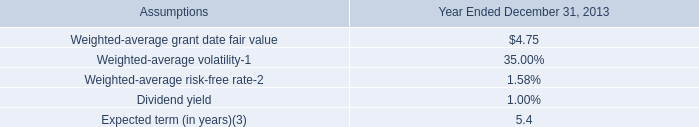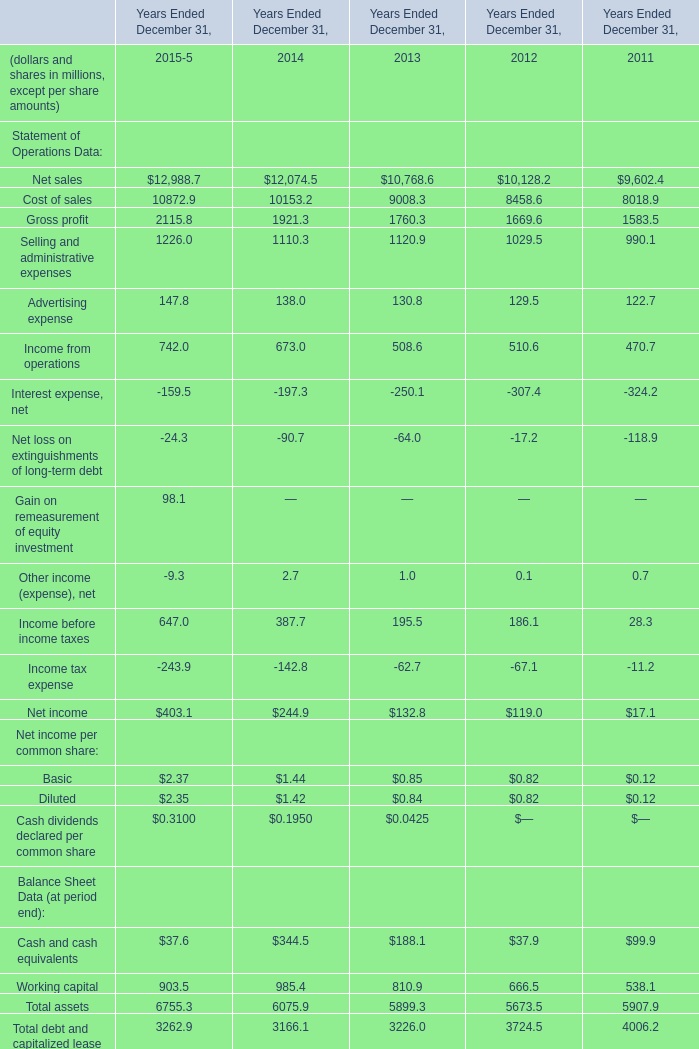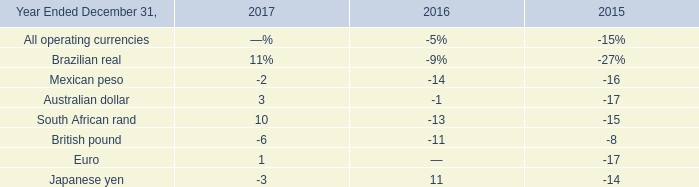Does Working capital keeps increasing each year between 2013 and 2015? 
Answer: No. 